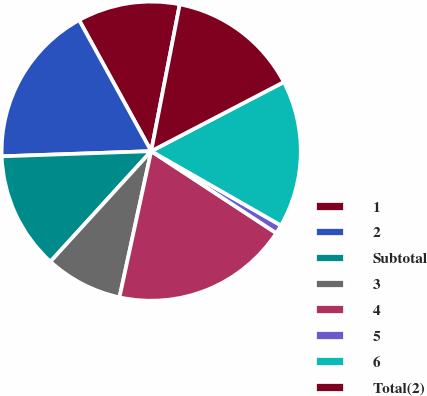Convert chart. <chart><loc_0><loc_0><loc_500><loc_500><pie_chart><fcel>1<fcel>2<fcel>Subtotal<fcel>3<fcel>4<fcel>5<fcel>6<fcel>Total(2)<nl><fcel>11.06%<fcel>17.55%<fcel>12.68%<fcel>8.37%<fcel>19.17%<fcel>0.96%<fcel>15.92%<fcel>14.3%<nl></chart> 